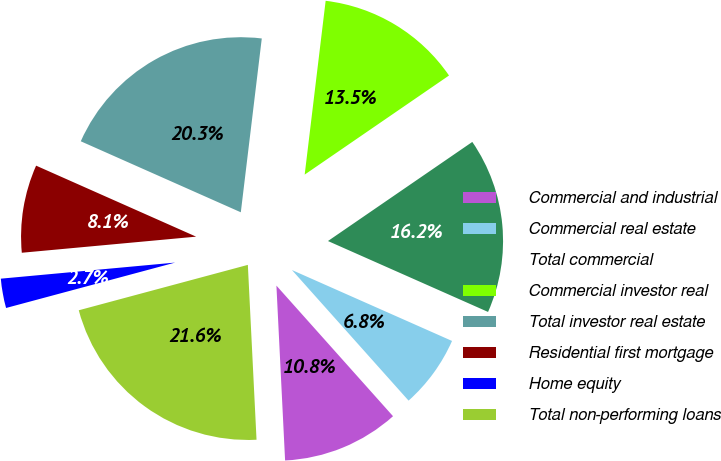<chart> <loc_0><loc_0><loc_500><loc_500><pie_chart><fcel>Commercial and industrial<fcel>Commercial real estate<fcel>Total commercial<fcel>Commercial investor real<fcel>Total investor real estate<fcel>Residential first mortgage<fcel>Home equity<fcel>Total non-performing loans<nl><fcel>10.81%<fcel>6.76%<fcel>16.21%<fcel>13.51%<fcel>20.26%<fcel>8.11%<fcel>2.71%<fcel>21.61%<nl></chart> 